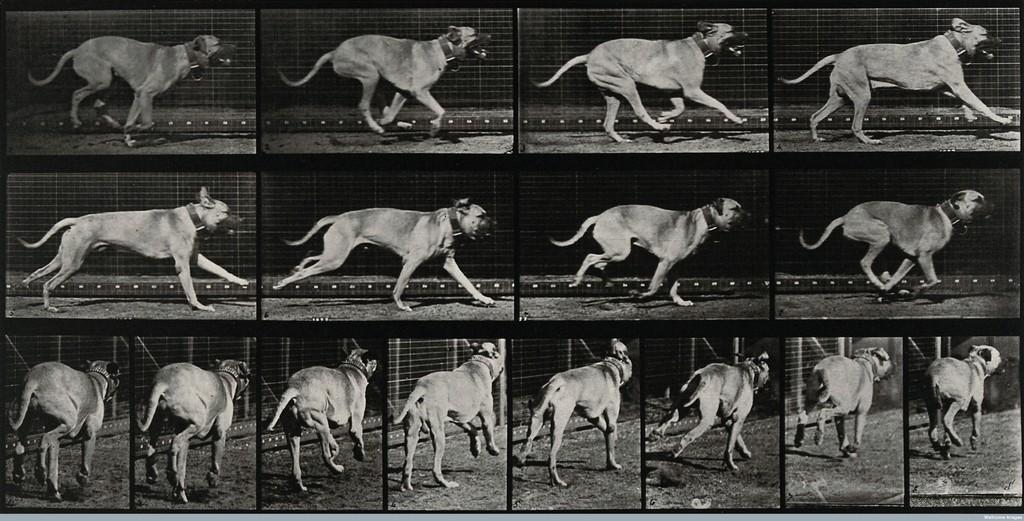How would you summarize this image in a sentence or two? This black and white picture is collage of different images. In all the images there is a dog. There is a belt around the neck of the dog. Behind the dog there is a fence. 